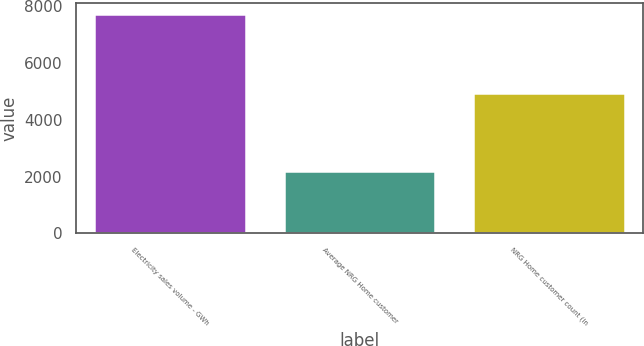Convert chart to OTSL. <chart><loc_0><loc_0><loc_500><loc_500><bar_chart><fcel>Electricity sales volume - GWh<fcel>Average NRG Home customer<fcel>NRG Home customer count (in<nl><fcel>7708.8<fcel>2190<fcel>4949.4<nl></chart> 